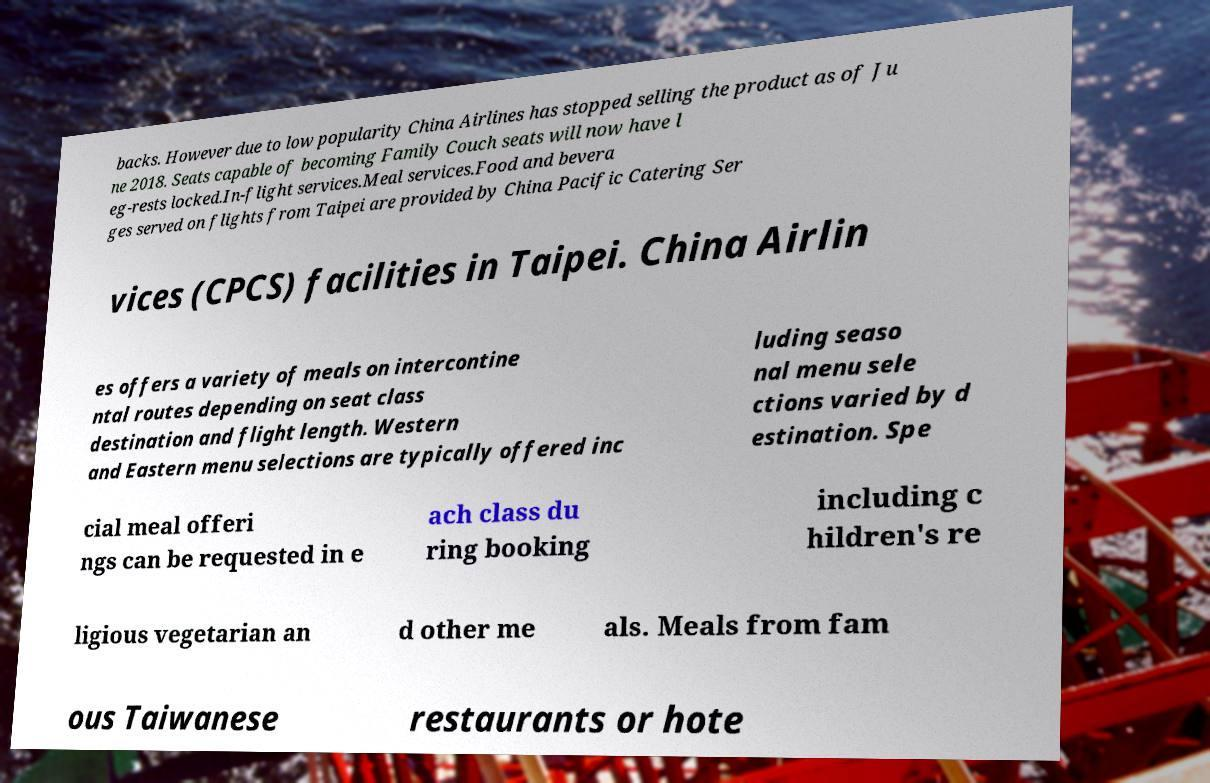Can you read and provide the text displayed in the image?This photo seems to have some interesting text. Can you extract and type it out for me? backs. However due to low popularity China Airlines has stopped selling the product as of Ju ne 2018. Seats capable of becoming Family Couch seats will now have l eg-rests locked.In-flight services.Meal services.Food and bevera ges served on flights from Taipei are provided by China Pacific Catering Ser vices (CPCS) facilities in Taipei. China Airlin es offers a variety of meals on intercontine ntal routes depending on seat class destination and flight length. Western and Eastern menu selections are typically offered inc luding seaso nal menu sele ctions varied by d estination. Spe cial meal offeri ngs can be requested in e ach class du ring booking including c hildren's re ligious vegetarian an d other me als. Meals from fam ous Taiwanese restaurants or hote 